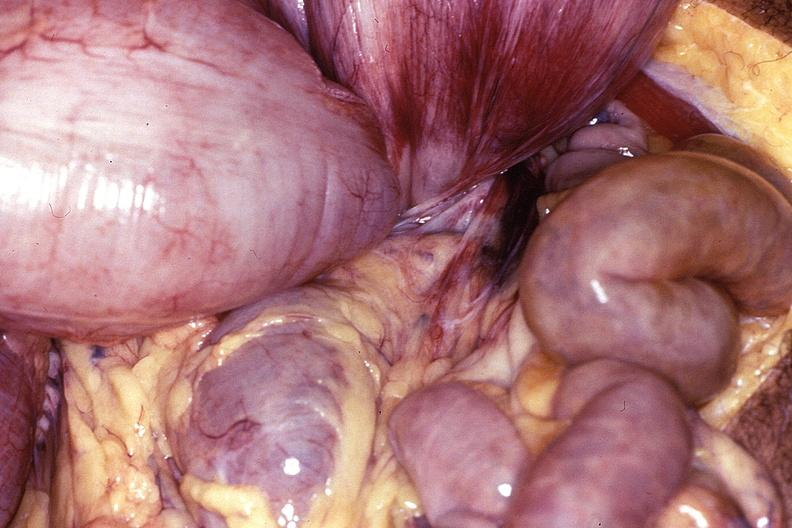s chest and abdomen slide present?
Answer the question using a single word or phrase. No 